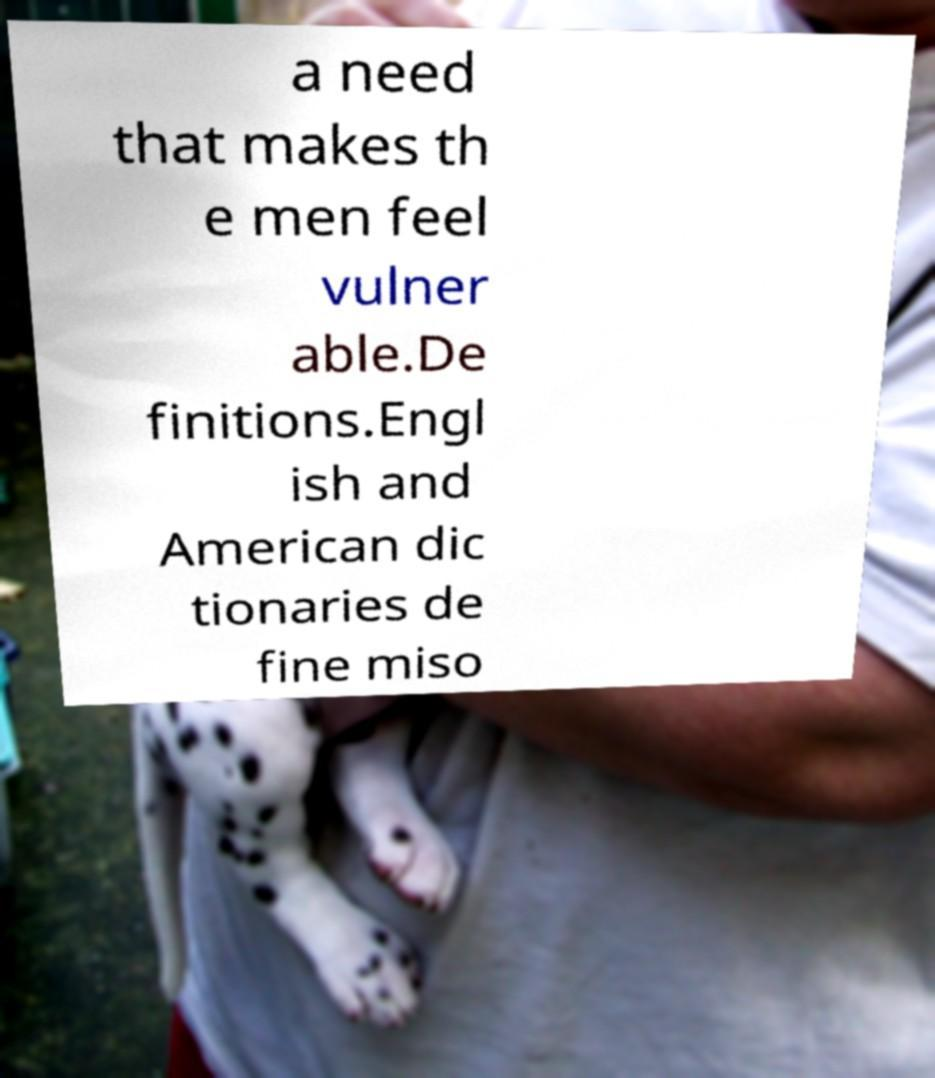Can you read and provide the text displayed in the image?This photo seems to have some interesting text. Can you extract and type it out for me? a need that makes th e men feel vulner able.De finitions.Engl ish and American dic tionaries de fine miso 